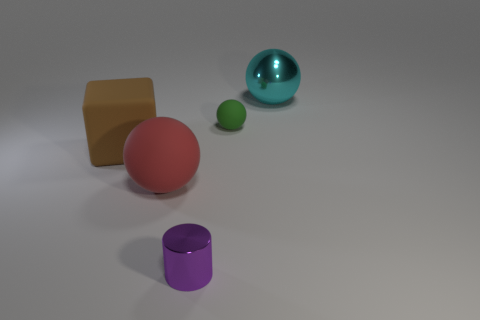Can you describe the lighting in the scene? The scene is softly lit with diffused light, creating gentle shadows on the ground and giving the objects a slightly muted appearance. The shadows suggest a single light source, albeit not too intense, likely positioned above the objects to the right, as inferred from the direction of the shadows. 